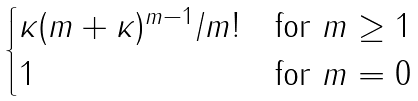Convert formula to latex. <formula><loc_0><loc_0><loc_500><loc_500>\begin{cases} \kappa ( m + \kappa ) ^ { m - 1 } / m ! & \text {for } m \geq 1 \\ 1 & \text {for } m = 0 \end{cases}</formula> 